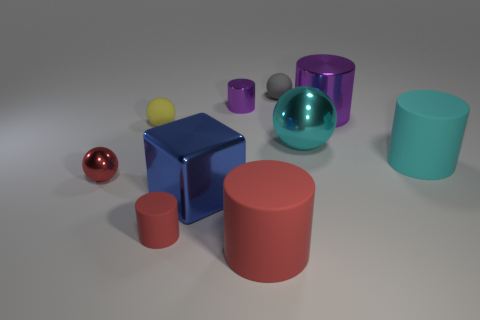There is a big thing that is both in front of the cyan matte object and right of the metallic cube; what is its shape? The object you're referring to is cylindrical in shape. It’s a large, vertical cylinder positioned to the front of the cyan matte cylinder and immediately to the right of the reflective blue metallic cube. 